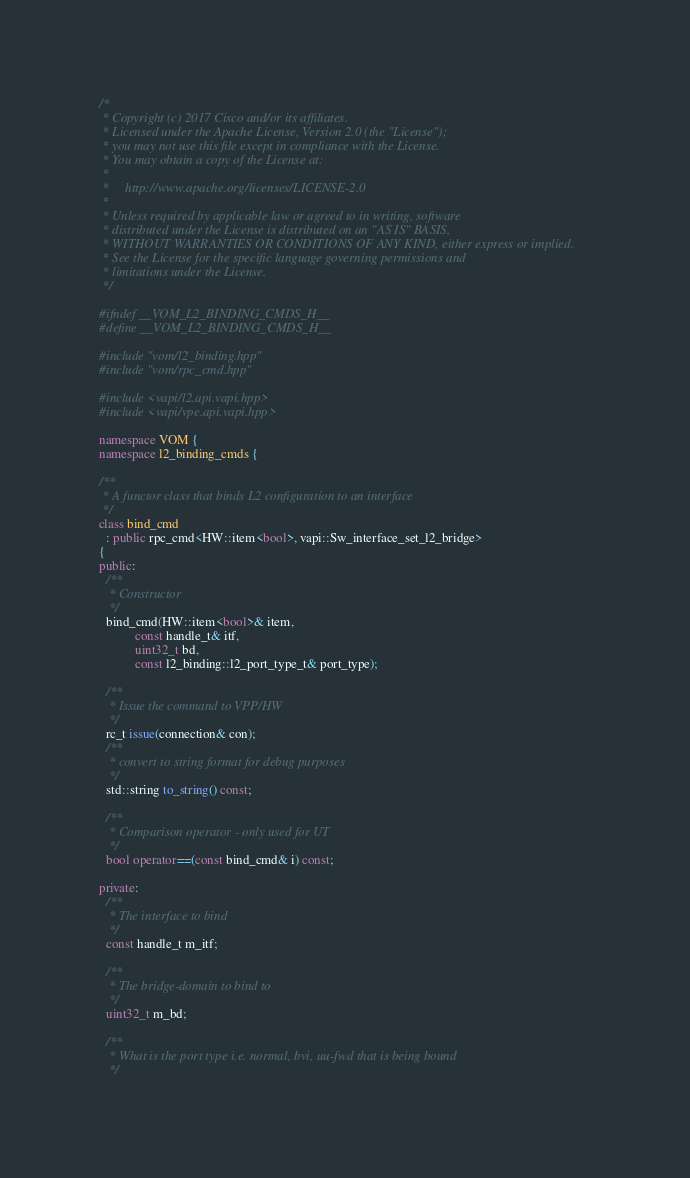Convert code to text. <code><loc_0><loc_0><loc_500><loc_500><_C++_>/*
 * Copyright (c) 2017 Cisco and/or its affiliates.
 * Licensed under the Apache License, Version 2.0 (the "License");
 * you may not use this file except in compliance with the License.
 * You may obtain a copy of the License at:
 *
 *     http://www.apache.org/licenses/LICENSE-2.0
 *
 * Unless required by applicable law or agreed to in writing, software
 * distributed under the License is distributed on an "AS IS" BASIS,
 * WITHOUT WARRANTIES OR CONDITIONS OF ANY KIND, either express or implied.
 * See the License for the specific language governing permissions and
 * limitations under the License.
 */

#ifndef __VOM_L2_BINDING_CMDS_H__
#define __VOM_L2_BINDING_CMDS_H__

#include "vom/l2_binding.hpp"
#include "vom/rpc_cmd.hpp"

#include <vapi/l2.api.vapi.hpp>
#include <vapi/vpe.api.vapi.hpp>

namespace VOM {
namespace l2_binding_cmds {

/**
 * A functor class that binds L2 configuration to an interface
 */
class bind_cmd
  : public rpc_cmd<HW::item<bool>, vapi::Sw_interface_set_l2_bridge>
{
public:
  /**
   * Constructor
   */
  bind_cmd(HW::item<bool>& item,
           const handle_t& itf,
           uint32_t bd,
           const l2_binding::l2_port_type_t& port_type);

  /**
   * Issue the command to VPP/HW
   */
  rc_t issue(connection& con);
  /**
   * convert to string format for debug purposes
   */
  std::string to_string() const;

  /**
   * Comparison operator - only used for UT
   */
  bool operator==(const bind_cmd& i) const;

private:
  /**
   * The interface to bind
   */
  const handle_t m_itf;

  /**
   * The bridge-domain to bind to
   */
  uint32_t m_bd;

  /**
   * What is the port type i.e. normal, bvi, uu-fwd that is being bound
   */</code> 